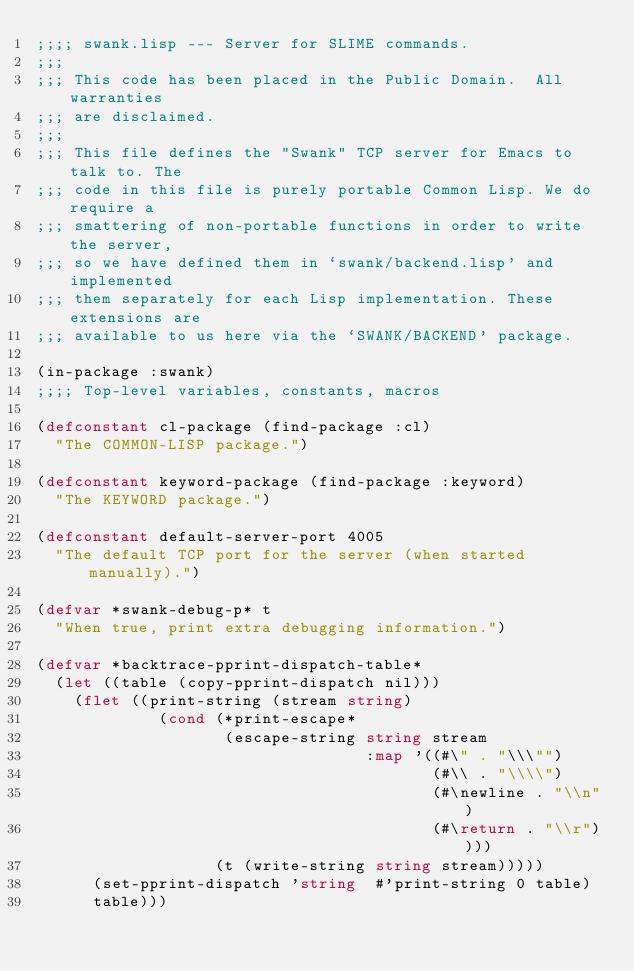<code> <loc_0><loc_0><loc_500><loc_500><_Lisp_>;;;; swank.lisp --- Server for SLIME commands.
;;;
;;; This code has been placed in the Public Domain.  All warranties
;;; are disclaimed.
;;;
;;; This file defines the "Swank" TCP server for Emacs to talk to. The
;;; code in this file is purely portable Common Lisp. We do require a
;;; smattering of non-portable functions in order to write the server,
;;; so we have defined them in `swank/backend.lisp' and implemented
;;; them separately for each Lisp implementation. These extensions are
;;; available to us here via the `SWANK/BACKEND' package.

(in-package :swank)
;;;; Top-level variables, constants, macros

(defconstant cl-package (find-package :cl)
  "The COMMON-LISP package.")

(defconstant keyword-package (find-package :keyword)
  "The KEYWORD package.")

(defconstant default-server-port 4005
  "The default TCP port for the server (when started manually).")

(defvar *swank-debug-p* t
  "When true, print extra debugging information.")

(defvar *backtrace-pprint-dispatch-table*
  (let ((table (copy-pprint-dispatch nil)))
    (flet ((print-string (stream string)
             (cond (*print-escape* 
                    (escape-string string stream
                                   :map '((#\" . "\\\"")
                                          (#\\ . "\\\\")
                                          (#\newline . "\\n")
                                          (#\return . "\\r"))))
                   (t (write-string string stream)))))
      (set-pprint-dispatch 'string  #'print-string 0 table)
      table)))
</code> 